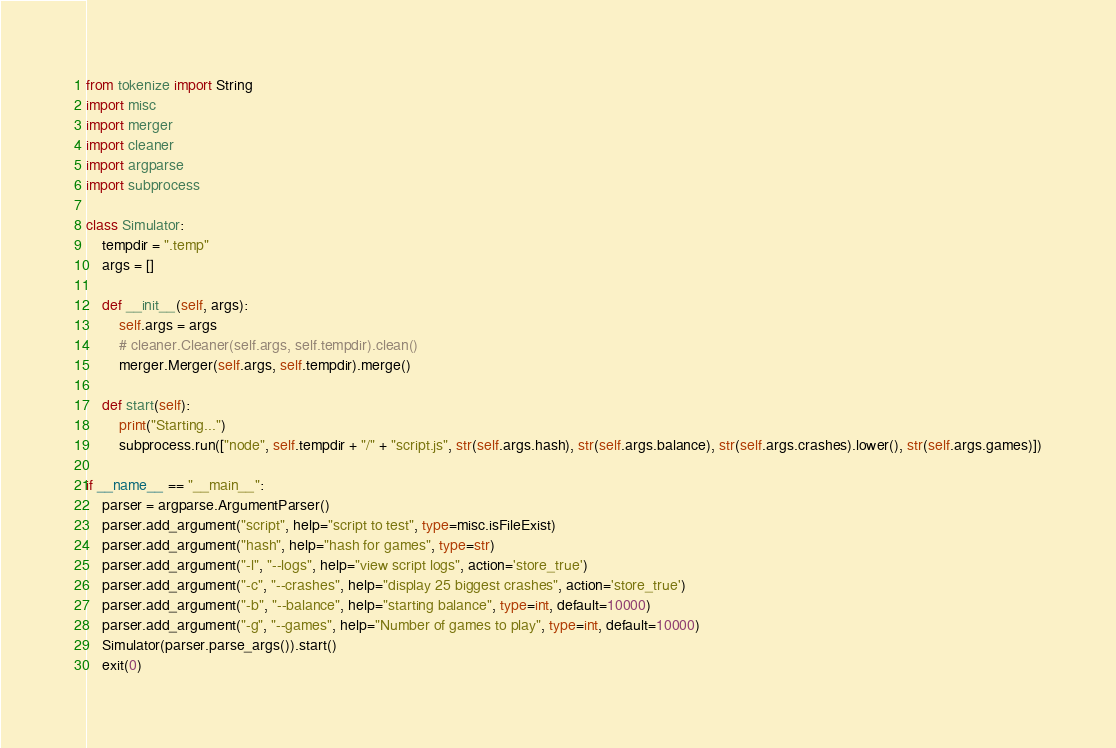<code> <loc_0><loc_0><loc_500><loc_500><_Python_>from tokenize import String
import misc
import merger
import cleaner
import argparse
import subprocess

class Simulator:
    tempdir = ".temp"
    args = []

    def __init__(self, args):
        self.args = args
        # cleaner.Cleaner(self.args, self.tempdir).clean()
        merger.Merger(self.args, self.tempdir).merge()

    def start(self):
        print("Starting...")
        subprocess.run(["node", self.tempdir + "/" + "script.js", str(self.args.hash), str(self.args.balance), str(self.args.crashes).lower(), str(self.args.games)])

if __name__ == "__main__":
    parser = argparse.ArgumentParser()
    parser.add_argument("script", help="script to test", type=misc.isFileExist)
    parser.add_argument("hash", help="hash for games", type=str)
    parser.add_argument("-l", "--logs", help="view script logs", action='store_true')
    parser.add_argument("-c", "--crashes", help="display 25 biggest crashes", action='store_true')
    parser.add_argument("-b", "--balance", help="starting balance", type=int, default=10000)
    parser.add_argument("-g", "--games", help="Number of games to play", type=int, default=10000)
    Simulator(parser.parse_args()).start()
    exit(0)</code> 